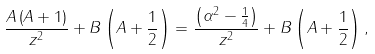Convert formula to latex. <formula><loc_0><loc_0><loc_500><loc_500>\frac { A \left ( A + 1 \right ) } { z ^ { 2 } } + B \left ( A + \frac { 1 } { 2 } \right ) = \frac { \left ( \alpha ^ { 2 } - \frac { 1 } { 4 } \right ) } { z ^ { 2 } } + B \left ( A + \frac { 1 } { 2 } \right ) ,</formula> 